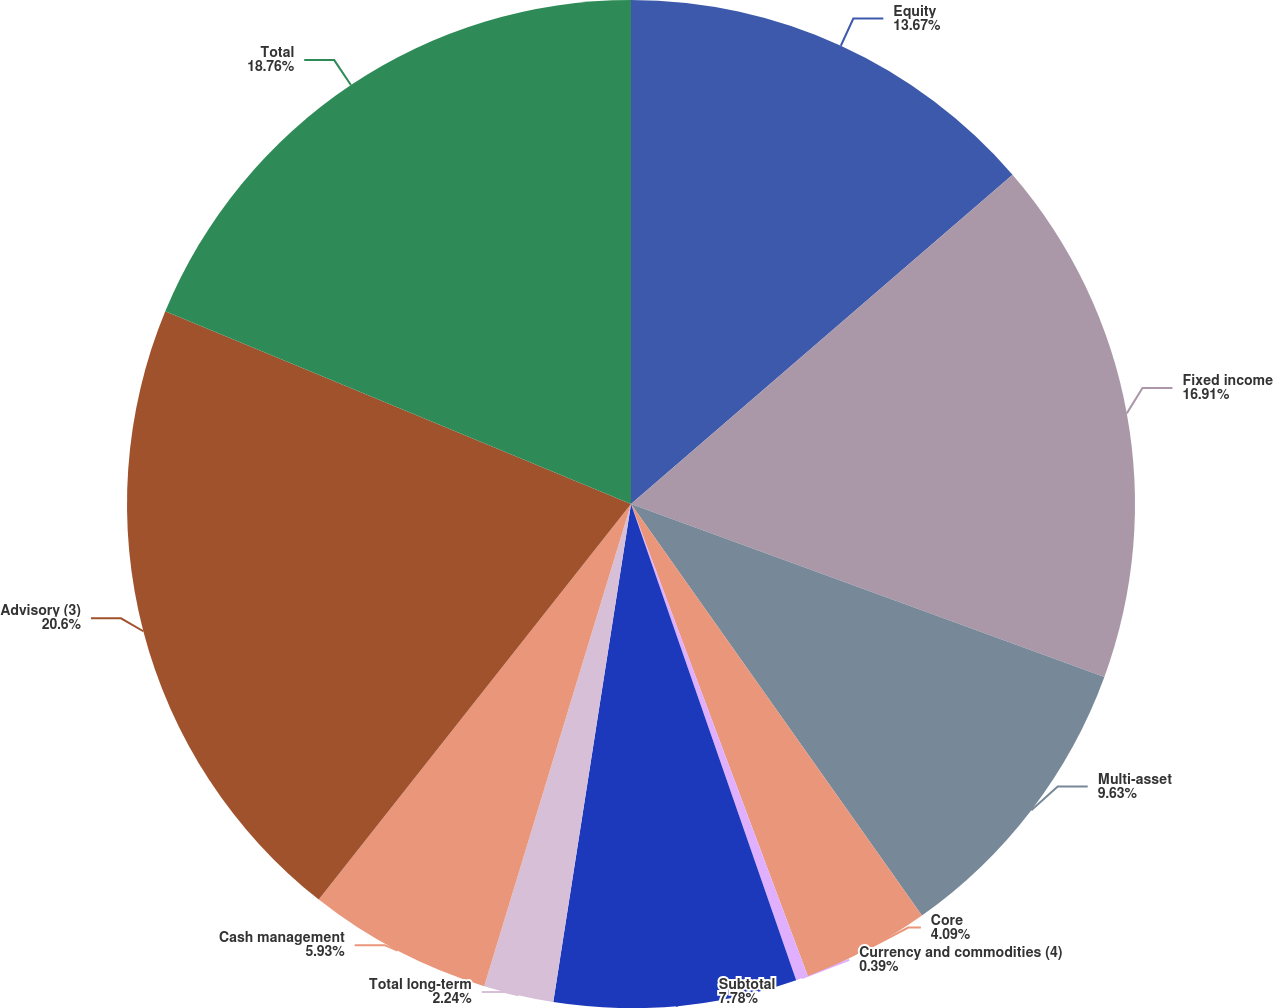Convert chart to OTSL. <chart><loc_0><loc_0><loc_500><loc_500><pie_chart><fcel>Equity<fcel>Fixed income<fcel>Multi-asset<fcel>Core<fcel>Currency and commodities (4)<fcel>Subtotal<fcel>Total long-term<fcel>Cash management<fcel>Advisory (3)<fcel>Total<nl><fcel>13.67%<fcel>16.91%<fcel>9.63%<fcel>4.09%<fcel>0.39%<fcel>7.78%<fcel>2.24%<fcel>5.93%<fcel>20.61%<fcel>18.76%<nl></chart> 